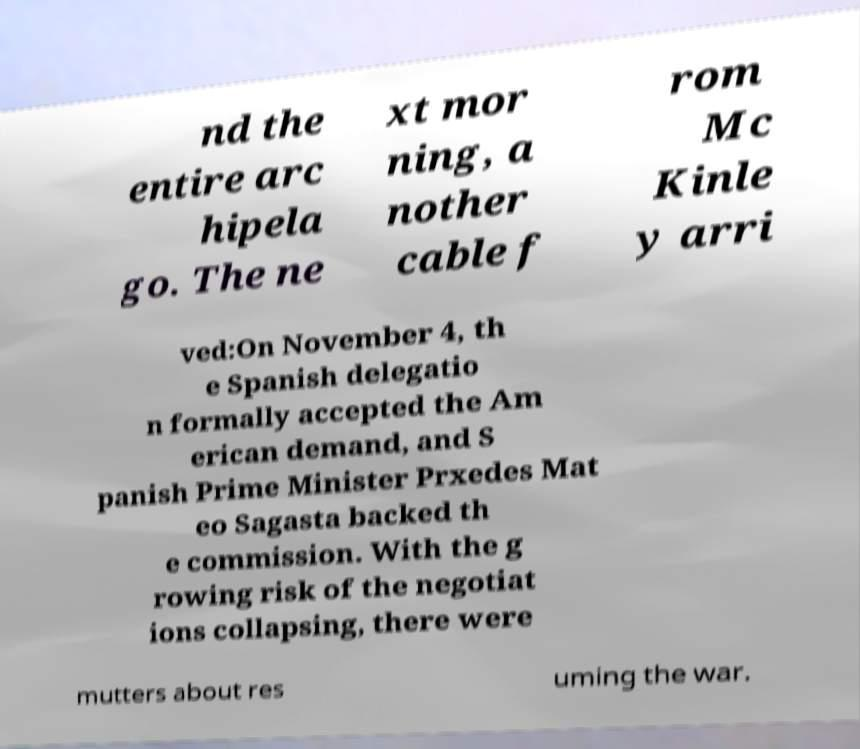I need the written content from this picture converted into text. Can you do that? nd the entire arc hipela go. The ne xt mor ning, a nother cable f rom Mc Kinle y arri ved:On November 4, th e Spanish delegatio n formally accepted the Am erican demand, and S panish Prime Minister Prxedes Mat eo Sagasta backed th e commission. With the g rowing risk of the negotiat ions collapsing, there were mutters about res uming the war. 